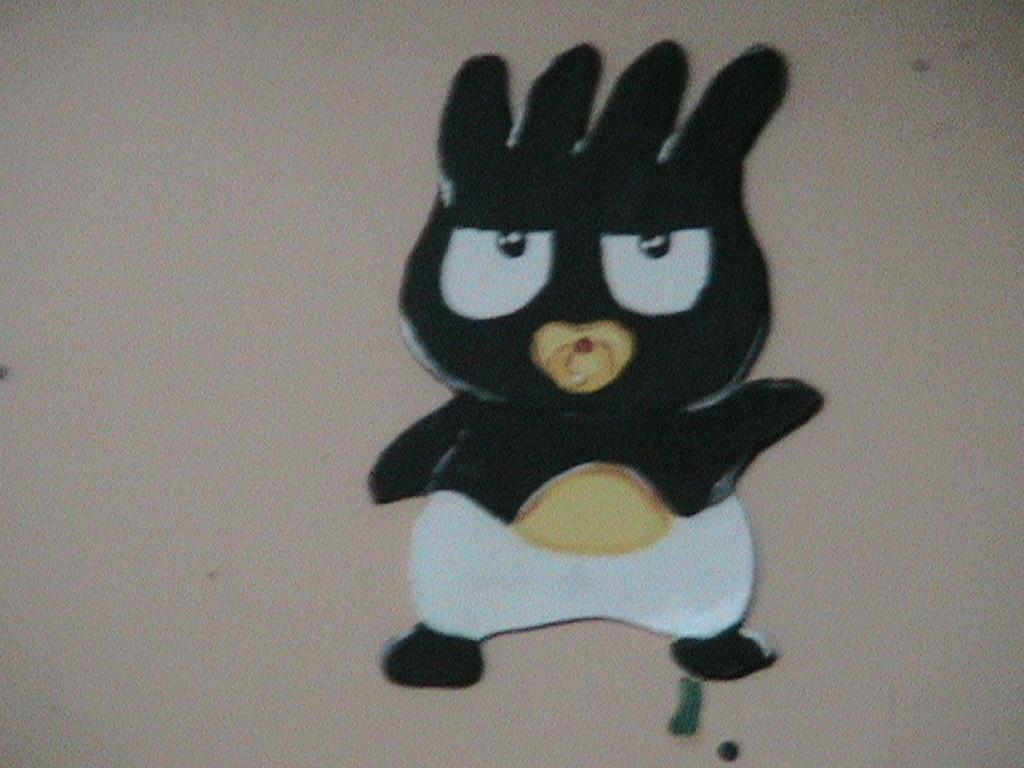What is the focus of the image? The image is zoomed in on a black color cartoon. Can you describe the cartoon in the center of the image? The cartoon is black in color and is the main subject of the image. What can be seen in the background of the image? There appears to be a wall in the background of the image. What type of holiday is being celebrated in the image? There is no indication of a holiday being celebrated in the image, as it features a black color cartoon and a wall in the background. What metal object is being used to eat the cartoon in the image? There is no metal object or any indication of eating in the image; it simply shows a black color cartoon and a wall in the background. 